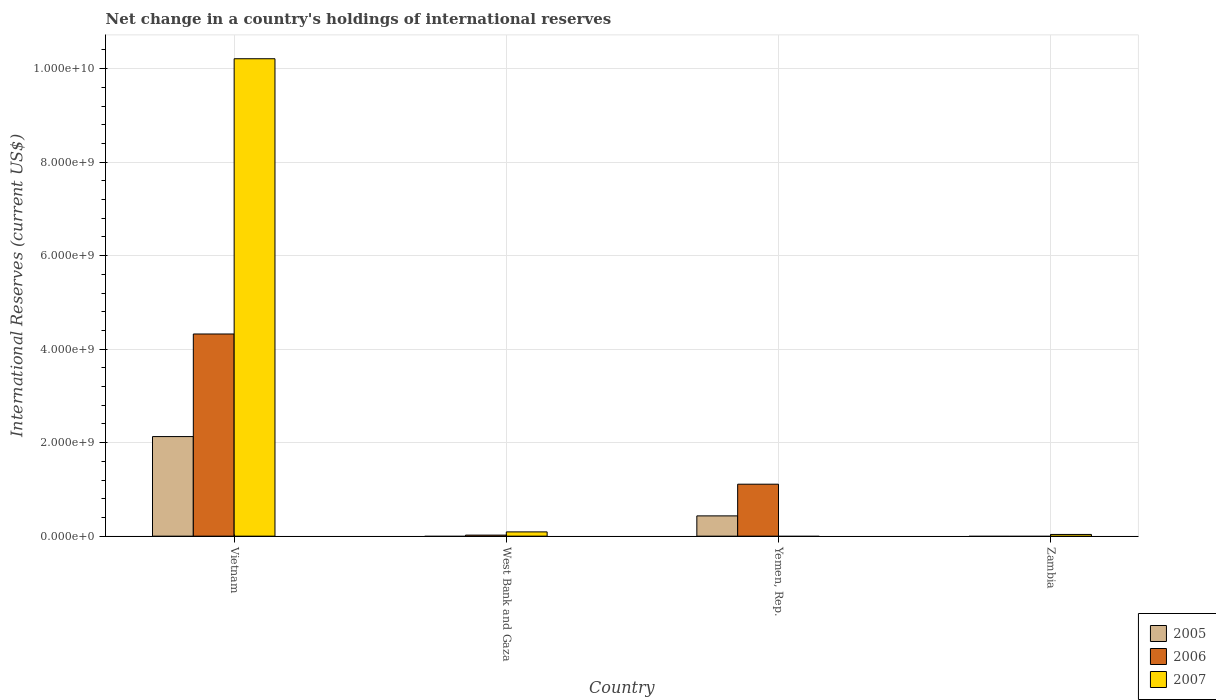Are the number of bars per tick equal to the number of legend labels?
Keep it short and to the point. No. Are the number of bars on each tick of the X-axis equal?
Make the answer very short. No. What is the label of the 1st group of bars from the left?
Give a very brief answer. Vietnam. In how many cases, is the number of bars for a given country not equal to the number of legend labels?
Offer a terse response. 3. What is the international reserves in 2005 in Zambia?
Your answer should be very brief. 0. Across all countries, what is the maximum international reserves in 2006?
Offer a terse response. 4.32e+09. In which country was the international reserves in 2006 maximum?
Keep it short and to the point. Vietnam. What is the total international reserves in 2007 in the graph?
Offer a very short reply. 1.03e+1. What is the difference between the international reserves in 2006 in Vietnam and that in Yemen, Rep.?
Keep it short and to the point. 3.21e+09. What is the difference between the international reserves in 2005 in Vietnam and the international reserves in 2007 in Zambia?
Make the answer very short. 2.09e+09. What is the average international reserves in 2006 per country?
Ensure brevity in your answer.  1.36e+09. What is the difference between the international reserves of/in 2007 and international reserves of/in 2005 in Vietnam?
Give a very brief answer. 8.08e+09. What is the ratio of the international reserves in 2006 in West Bank and Gaza to that in Yemen, Rep.?
Offer a terse response. 0.02. Is the international reserves in 2006 in Vietnam less than that in West Bank and Gaza?
Give a very brief answer. No. What is the difference between the highest and the second highest international reserves in 2006?
Keep it short and to the point. -1.09e+09. What is the difference between the highest and the lowest international reserves in 2005?
Your answer should be compact. 2.13e+09. Is the sum of the international reserves in 2006 in West Bank and Gaza and Yemen, Rep. greater than the maximum international reserves in 2007 across all countries?
Provide a short and direct response. No. Is it the case that in every country, the sum of the international reserves in 2006 and international reserves in 2007 is greater than the international reserves in 2005?
Give a very brief answer. Yes. How many bars are there?
Your answer should be very brief. 8. Are all the bars in the graph horizontal?
Offer a terse response. No. How many countries are there in the graph?
Give a very brief answer. 4. What is the difference between two consecutive major ticks on the Y-axis?
Keep it short and to the point. 2.00e+09. Does the graph contain grids?
Ensure brevity in your answer.  Yes. Where does the legend appear in the graph?
Give a very brief answer. Bottom right. How many legend labels are there?
Provide a succinct answer. 3. How are the legend labels stacked?
Provide a short and direct response. Vertical. What is the title of the graph?
Give a very brief answer. Net change in a country's holdings of international reserves. Does "2009" appear as one of the legend labels in the graph?
Your response must be concise. No. What is the label or title of the Y-axis?
Your response must be concise. International Reserves (current US$). What is the International Reserves (current US$) of 2005 in Vietnam?
Keep it short and to the point. 2.13e+09. What is the International Reserves (current US$) of 2006 in Vietnam?
Make the answer very short. 4.32e+09. What is the International Reserves (current US$) of 2007 in Vietnam?
Your answer should be very brief. 1.02e+1. What is the International Reserves (current US$) of 2006 in West Bank and Gaza?
Your answer should be compact. 2.23e+07. What is the International Reserves (current US$) in 2007 in West Bank and Gaza?
Offer a terse response. 9.13e+07. What is the International Reserves (current US$) in 2005 in Yemen, Rep.?
Provide a succinct answer. 4.34e+08. What is the International Reserves (current US$) in 2006 in Yemen, Rep.?
Ensure brevity in your answer.  1.11e+09. What is the International Reserves (current US$) in 2007 in Yemen, Rep.?
Offer a very short reply. 0. What is the International Reserves (current US$) of 2005 in Zambia?
Your answer should be compact. 0. What is the International Reserves (current US$) of 2006 in Zambia?
Ensure brevity in your answer.  0. What is the International Reserves (current US$) of 2007 in Zambia?
Provide a short and direct response. 3.68e+07. Across all countries, what is the maximum International Reserves (current US$) in 2005?
Your answer should be compact. 2.13e+09. Across all countries, what is the maximum International Reserves (current US$) of 2006?
Your response must be concise. 4.32e+09. Across all countries, what is the maximum International Reserves (current US$) in 2007?
Offer a terse response. 1.02e+1. Across all countries, what is the minimum International Reserves (current US$) of 2006?
Provide a succinct answer. 0. What is the total International Reserves (current US$) in 2005 in the graph?
Give a very brief answer. 2.56e+09. What is the total International Reserves (current US$) of 2006 in the graph?
Keep it short and to the point. 5.46e+09. What is the total International Reserves (current US$) in 2007 in the graph?
Offer a terse response. 1.03e+1. What is the difference between the International Reserves (current US$) of 2006 in Vietnam and that in West Bank and Gaza?
Offer a very short reply. 4.30e+09. What is the difference between the International Reserves (current US$) of 2007 in Vietnam and that in West Bank and Gaza?
Offer a terse response. 1.01e+1. What is the difference between the International Reserves (current US$) of 2005 in Vietnam and that in Yemen, Rep.?
Keep it short and to the point. 1.70e+09. What is the difference between the International Reserves (current US$) of 2006 in Vietnam and that in Yemen, Rep.?
Keep it short and to the point. 3.21e+09. What is the difference between the International Reserves (current US$) in 2007 in Vietnam and that in Zambia?
Provide a succinct answer. 1.02e+1. What is the difference between the International Reserves (current US$) in 2006 in West Bank and Gaza and that in Yemen, Rep.?
Provide a short and direct response. -1.09e+09. What is the difference between the International Reserves (current US$) in 2007 in West Bank and Gaza and that in Zambia?
Your answer should be very brief. 5.45e+07. What is the difference between the International Reserves (current US$) in 2005 in Vietnam and the International Reserves (current US$) in 2006 in West Bank and Gaza?
Offer a very short reply. 2.11e+09. What is the difference between the International Reserves (current US$) in 2005 in Vietnam and the International Reserves (current US$) in 2007 in West Bank and Gaza?
Make the answer very short. 2.04e+09. What is the difference between the International Reserves (current US$) in 2006 in Vietnam and the International Reserves (current US$) in 2007 in West Bank and Gaza?
Make the answer very short. 4.23e+09. What is the difference between the International Reserves (current US$) of 2005 in Vietnam and the International Reserves (current US$) of 2006 in Yemen, Rep.?
Ensure brevity in your answer.  1.02e+09. What is the difference between the International Reserves (current US$) in 2005 in Vietnam and the International Reserves (current US$) in 2007 in Zambia?
Provide a short and direct response. 2.09e+09. What is the difference between the International Reserves (current US$) in 2006 in Vietnam and the International Reserves (current US$) in 2007 in Zambia?
Keep it short and to the point. 4.29e+09. What is the difference between the International Reserves (current US$) in 2006 in West Bank and Gaza and the International Reserves (current US$) in 2007 in Zambia?
Provide a succinct answer. -1.45e+07. What is the difference between the International Reserves (current US$) of 2005 in Yemen, Rep. and the International Reserves (current US$) of 2007 in Zambia?
Your response must be concise. 3.97e+08. What is the difference between the International Reserves (current US$) in 2006 in Yemen, Rep. and the International Reserves (current US$) in 2007 in Zambia?
Your answer should be very brief. 1.07e+09. What is the average International Reserves (current US$) of 2005 per country?
Offer a terse response. 6.41e+08. What is the average International Reserves (current US$) of 2006 per country?
Provide a short and direct response. 1.36e+09. What is the average International Reserves (current US$) of 2007 per country?
Offer a terse response. 2.58e+09. What is the difference between the International Reserves (current US$) of 2005 and International Reserves (current US$) of 2006 in Vietnam?
Your response must be concise. -2.19e+09. What is the difference between the International Reserves (current US$) of 2005 and International Reserves (current US$) of 2007 in Vietnam?
Offer a terse response. -8.08e+09. What is the difference between the International Reserves (current US$) of 2006 and International Reserves (current US$) of 2007 in Vietnam?
Provide a short and direct response. -5.89e+09. What is the difference between the International Reserves (current US$) in 2006 and International Reserves (current US$) in 2007 in West Bank and Gaza?
Make the answer very short. -6.90e+07. What is the difference between the International Reserves (current US$) of 2005 and International Reserves (current US$) of 2006 in Yemen, Rep.?
Your answer should be very brief. -6.78e+08. What is the ratio of the International Reserves (current US$) of 2006 in Vietnam to that in West Bank and Gaza?
Your answer should be very brief. 193.78. What is the ratio of the International Reserves (current US$) in 2007 in Vietnam to that in West Bank and Gaza?
Keep it short and to the point. 111.87. What is the ratio of the International Reserves (current US$) of 2005 in Vietnam to that in Yemen, Rep.?
Your response must be concise. 4.91. What is the ratio of the International Reserves (current US$) in 2006 in Vietnam to that in Yemen, Rep.?
Provide a succinct answer. 3.89. What is the ratio of the International Reserves (current US$) of 2007 in Vietnam to that in Zambia?
Your answer should be compact. 277.4. What is the ratio of the International Reserves (current US$) of 2006 in West Bank and Gaza to that in Yemen, Rep.?
Offer a terse response. 0.02. What is the ratio of the International Reserves (current US$) of 2007 in West Bank and Gaza to that in Zambia?
Ensure brevity in your answer.  2.48. What is the difference between the highest and the second highest International Reserves (current US$) in 2006?
Offer a very short reply. 3.21e+09. What is the difference between the highest and the second highest International Reserves (current US$) in 2007?
Provide a short and direct response. 1.01e+1. What is the difference between the highest and the lowest International Reserves (current US$) in 2005?
Provide a short and direct response. 2.13e+09. What is the difference between the highest and the lowest International Reserves (current US$) in 2006?
Your answer should be very brief. 4.32e+09. What is the difference between the highest and the lowest International Reserves (current US$) in 2007?
Ensure brevity in your answer.  1.02e+1. 